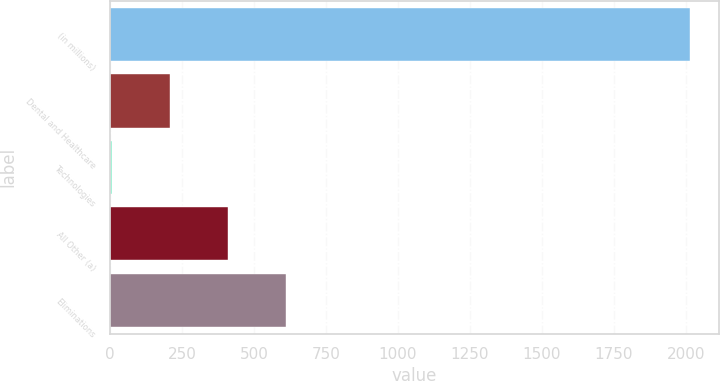<chart> <loc_0><loc_0><loc_500><loc_500><bar_chart><fcel>(in millions)<fcel>Dental and Healthcare<fcel>Technologies<fcel>All Other (a)<fcel>Eliminations<nl><fcel>2015<fcel>208.07<fcel>7.3<fcel>408.84<fcel>609.61<nl></chart> 